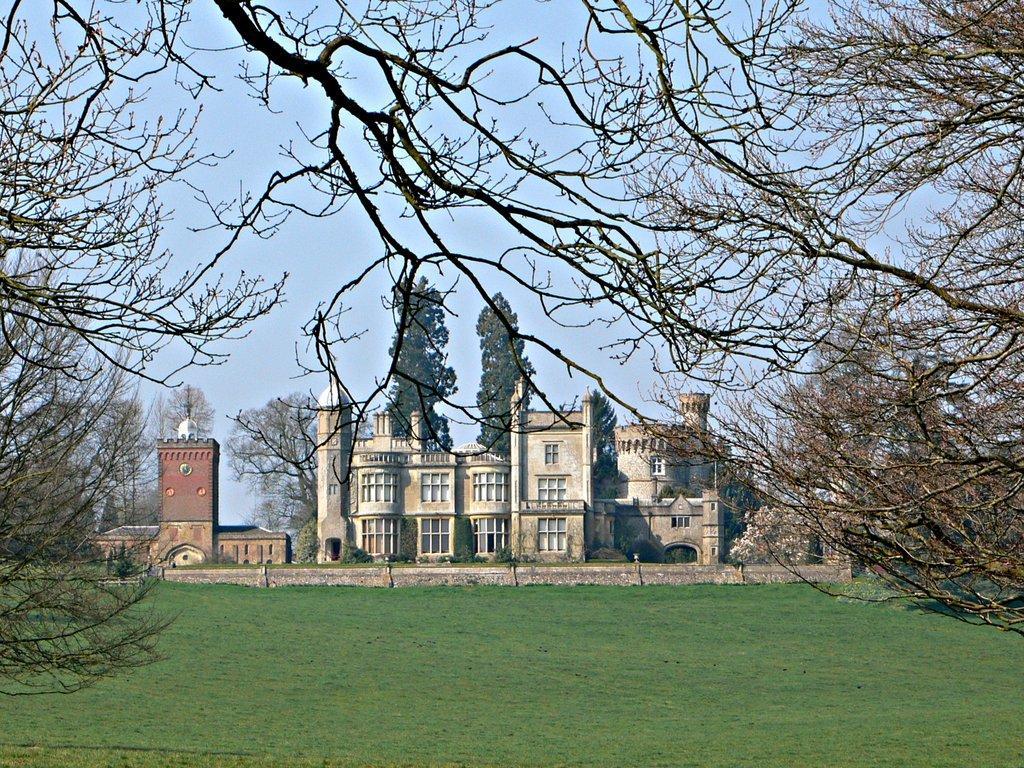Could you give a brief overview of what you see in this image? We can see trees and grass. In the background we can see wall, buildings, plants, trees and sky. 